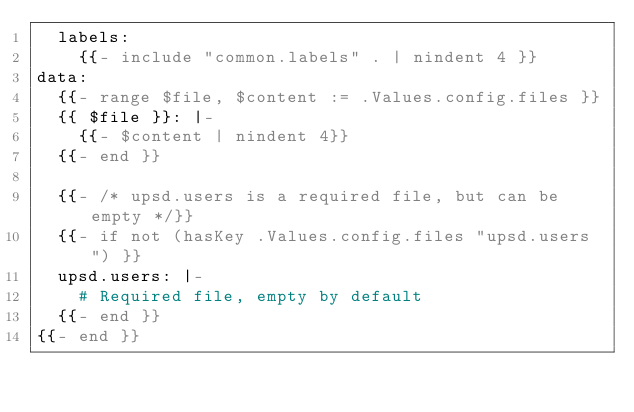Convert code to text. <code><loc_0><loc_0><loc_500><loc_500><_YAML_>  labels:
    {{- include "common.labels" . | nindent 4 }}
data:
  {{- range $file, $content := .Values.config.files }}
  {{ $file }}: |-
    {{- $content | nindent 4}}
  {{- end }}

  {{- /* upsd.users is a required file, but can be empty */}}
  {{- if not (hasKey .Values.config.files "upsd.users") }}
  upsd.users: |-
    # Required file, empty by default
  {{- end }}
{{- end }}
</code> 